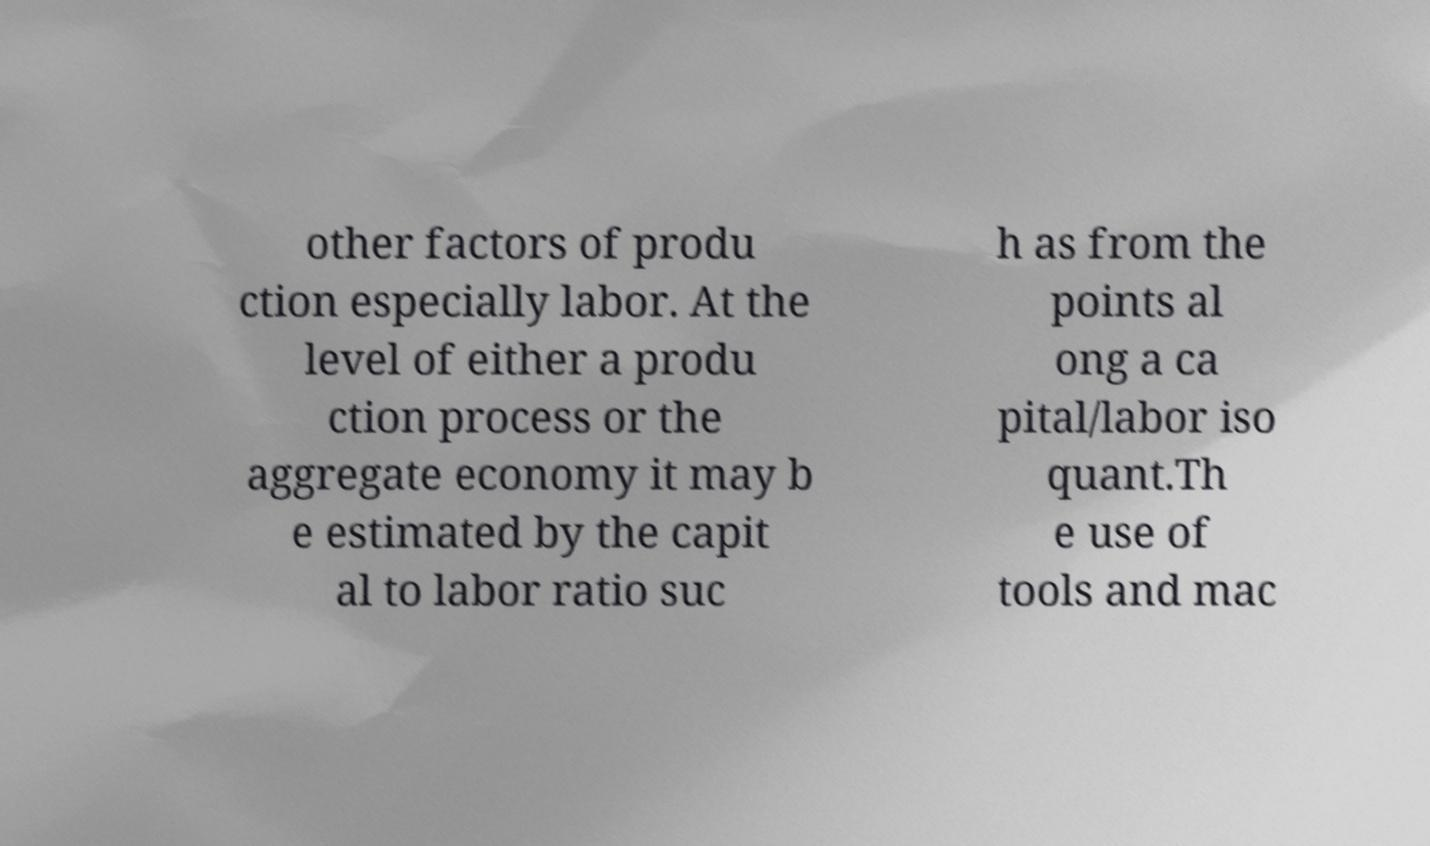What messages or text are displayed in this image? I need them in a readable, typed format. other factors of produ ction especially labor. At the level of either a produ ction process or the aggregate economy it may b e estimated by the capit al to labor ratio suc h as from the points al ong a ca pital/labor iso quant.Th e use of tools and mac 